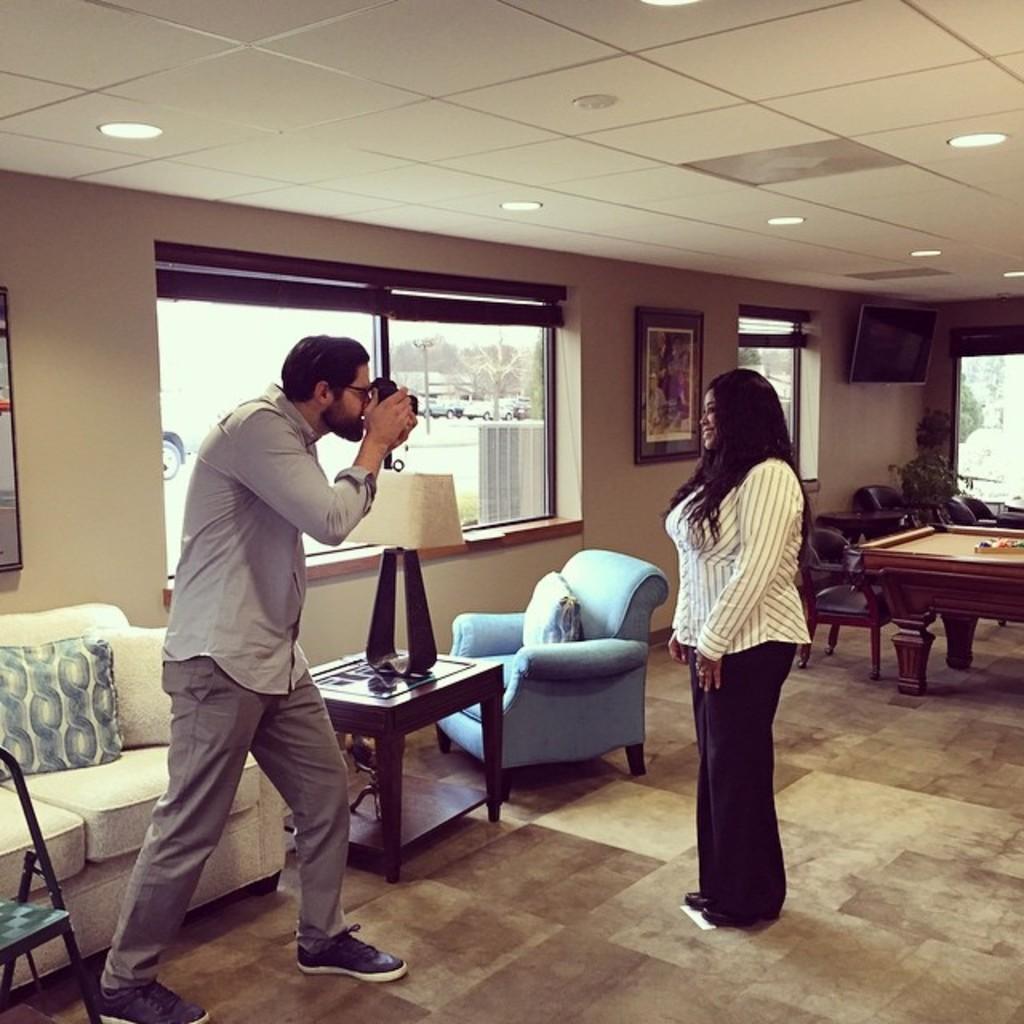Can you describe this image briefly? The image consists of a man taking picture of a woman,it seems to be in a living room. There is sofa on back side of the man and in front there is a lamp and on ceiling there are lights. 